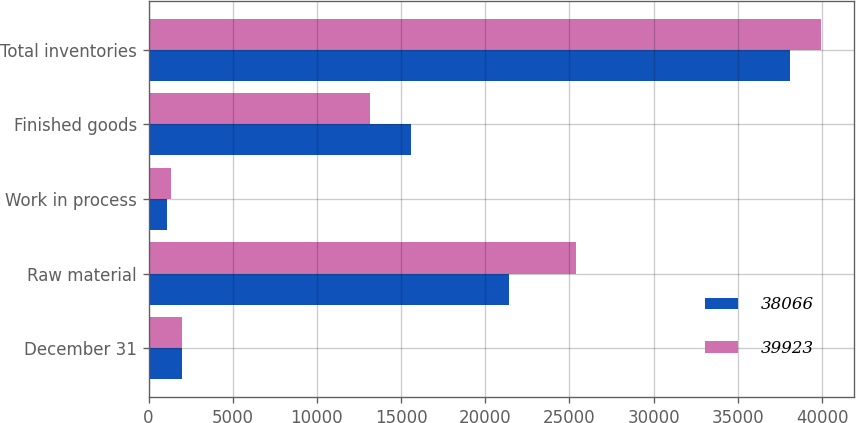Convert chart. <chart><loc_0><loc_0><loc_500><loc_500><stacked_bar_chart><ecel><fcel>December 31<fcel>Raw material<fcel>Work in process<fcel>Finished goods<fcel>Total inventories<nl><fcel>38066<fcel>2002<fcel>21404<fcel>1104<fcel>15558<fcel>38066<nl><fcel>39923<fcel>2001<fcel>25410<fcel>1360<fcel>13153<fcel>39923<nl></chart> 